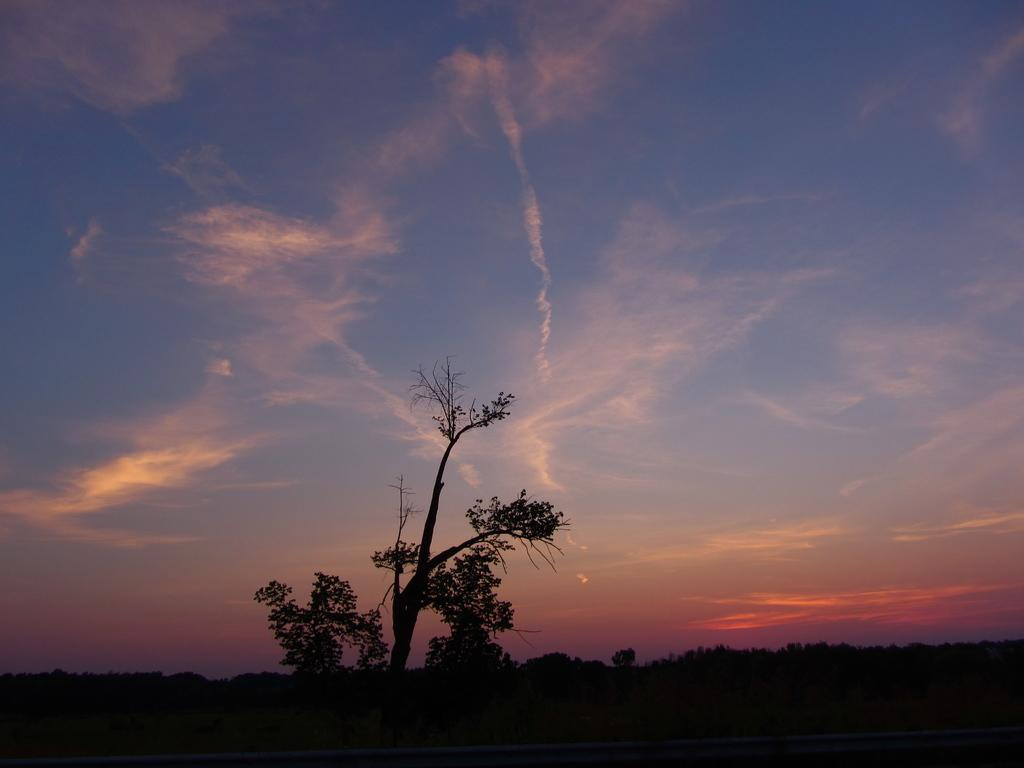What type of vegetation can be seen in the image? There are trees in the image. What can be seen in the sky in the background of the image? There are clouds in the sky in the background of the image. What type of zephyr can be seen in the image? There is no zephyr present in the image. What is the relation between the trees and the clouds in the image? The provided facts do not mention any relation between the trees and the clouds in the image. 